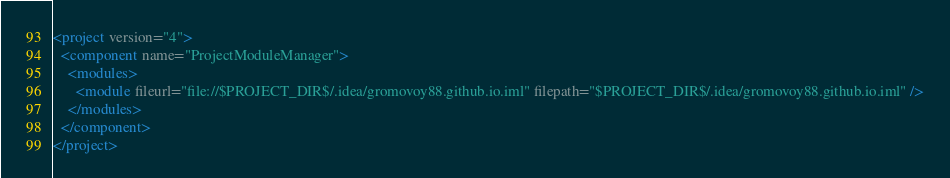<code> <loc_0><loc_0><loc_500><loc_500><_XML_><project version="4">
  <component name="ProjectModuleManager">
    <modules>
      <module fileurl="file://$PROJECT_DIR$/.idea/gromovoy88.github.io.iml" filepath="$PROJECT_DIR$/.idea/gromovoy88.github.io.iml" />
    </modules>
  </component>
</project></code> 